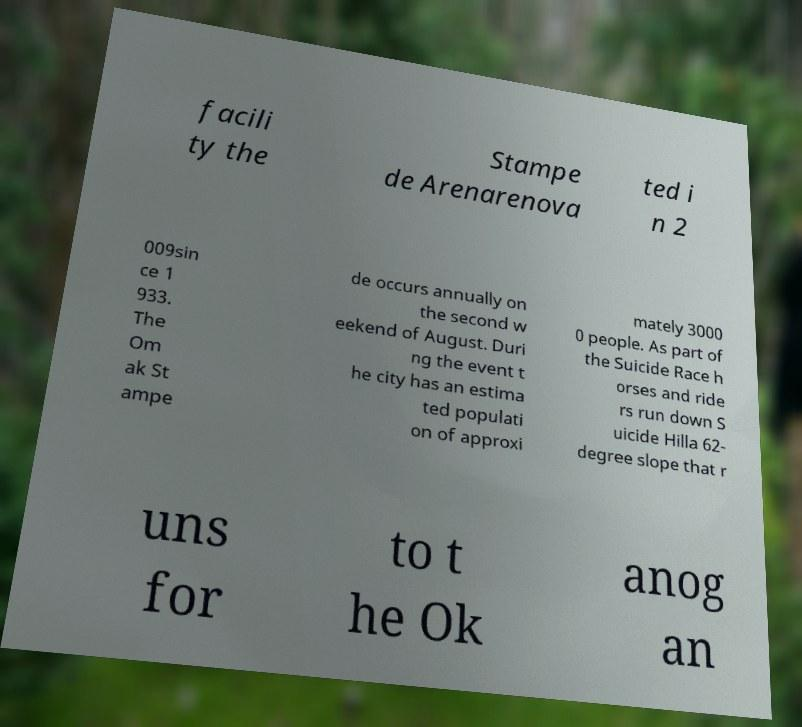Could you extract and type out the text from this image? facili ty the Stampe de Arenarenova ted i n 2 009sin ce 1 933. The Om ak St ampe de occurs annually on the second w eekend of August. Duri ng the event t he city has an estima ted populati on of approxi mately 3000 0 people. As part of the Suicide Race h orses and ride rs run down S uicide Hilla 62- degree slope that r uns for to t he Ok anog an 